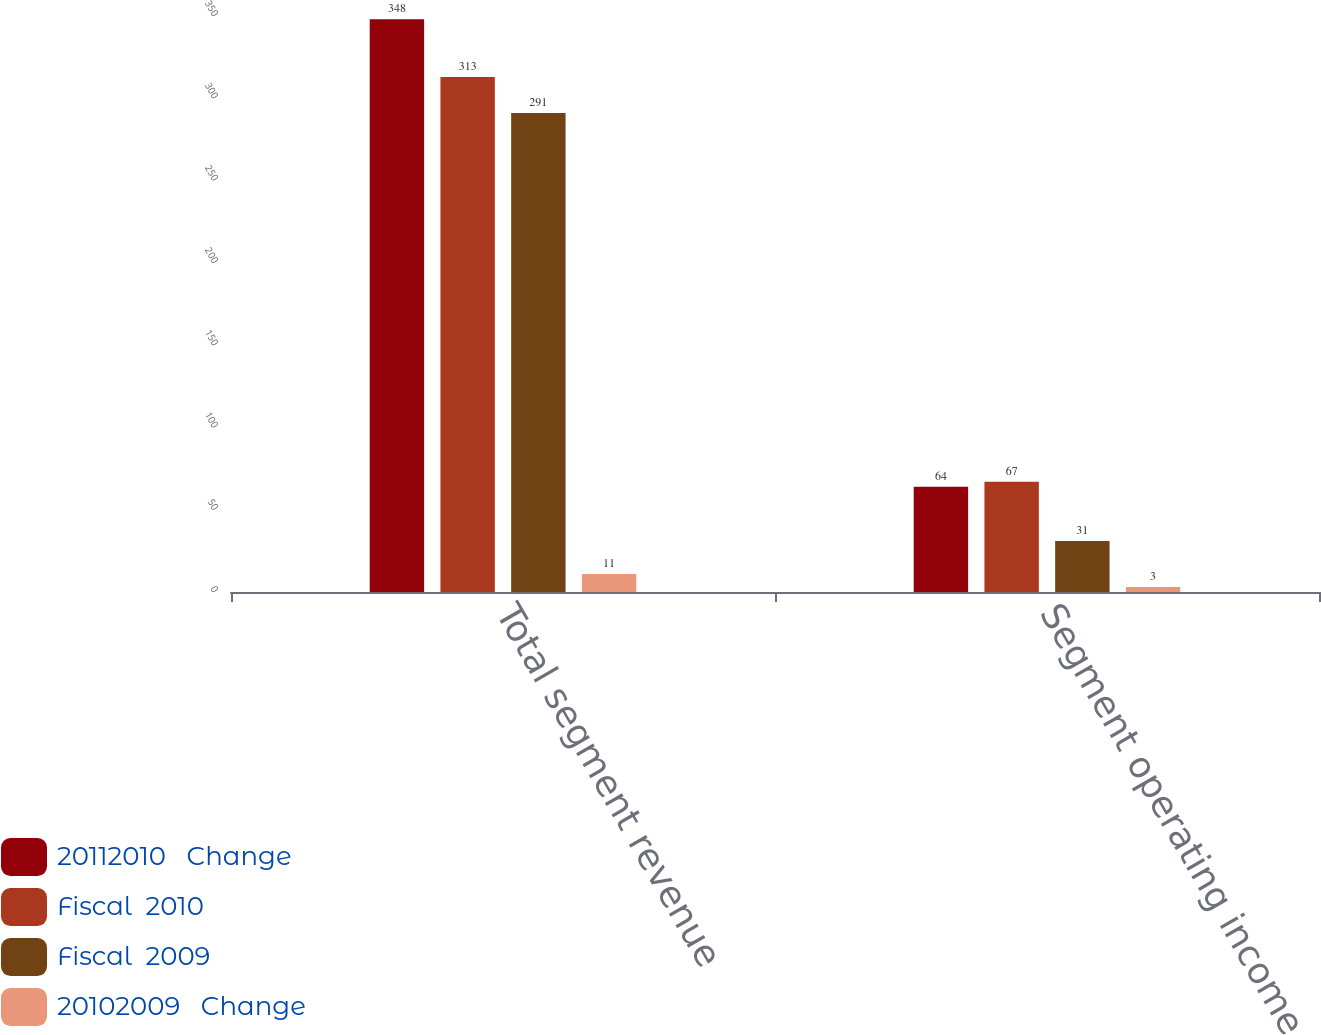<chart> <loc_0><loc_0><loc_500><loc_500><stacked_bar_chart><ecel><fcel>Total segment revenue<fcel>Segment operating income<nl><fcel>20112010   Change<fcel>348<fcel>64<nl><fcel>Fiscal  2010<fcel>313<fcel>67<nl><fcel>Fiscal  2009<fcel>291<fcel>31<nl><fcel>20102009   Change<fcel>11<fcel>3<nl></chart> 